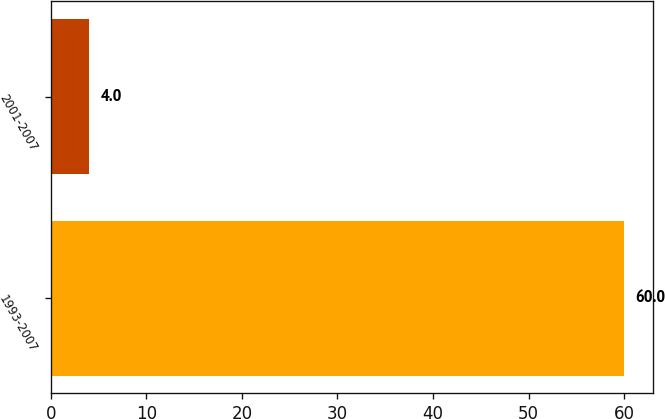Convert chart to OTSL. <chart><loc_0><loc_0><loc_500><loc_500><bar_chart><fcel>1993-2007<fcel>2001-2007<nl><fcel>60<fcel>4<nl></chart> 